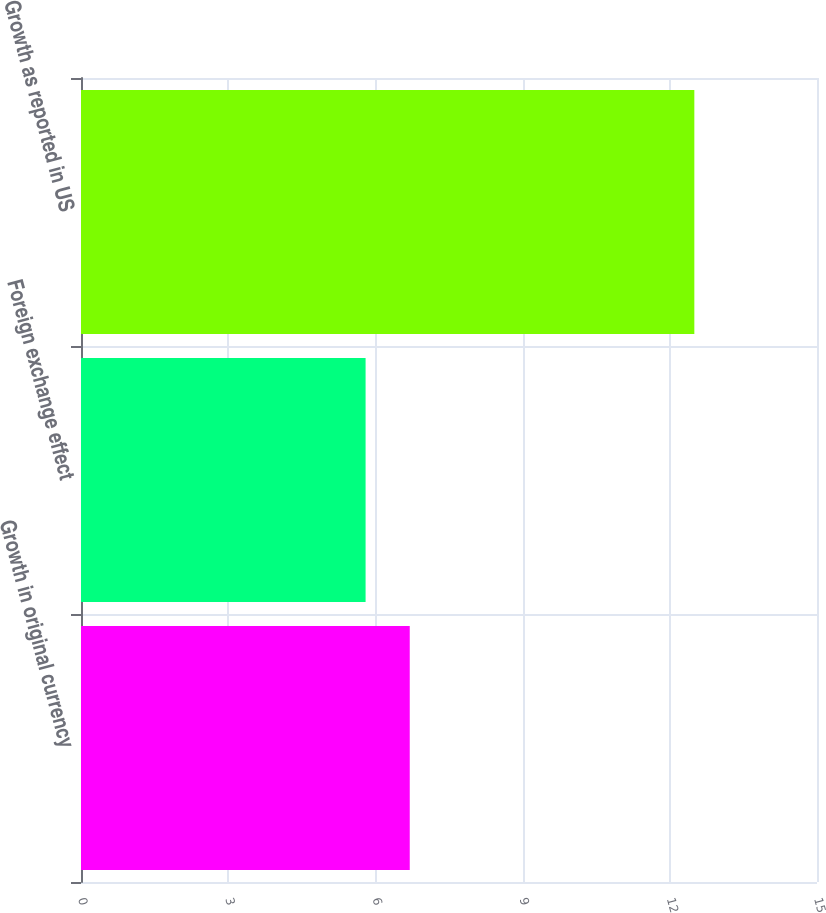Convert chart. <chart><loc_0><loc_0><loc_500><loc_500><bar_chart><fcel>Growth in original currency<fcel>Foreign exchange effect<fcel>Growth as reported in US<nl><fcel>6.7<fcel>5.8<fcel>12.5<nl></chart> 